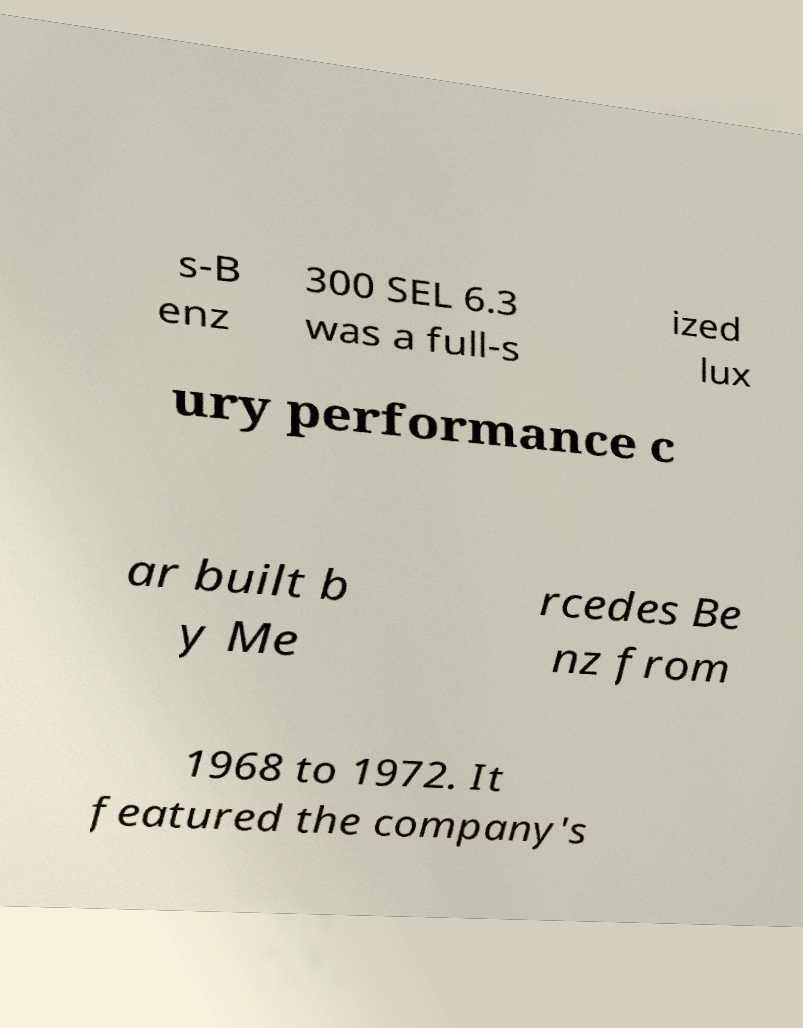What messages or text are displayed in this image? I need them in a readable, typed format. s-B enz 300 SEL 6.3 was a full-s ized lux ury performance c ar built b y Me rcedes Be nz from 1968 to 1972. It featured the company's 